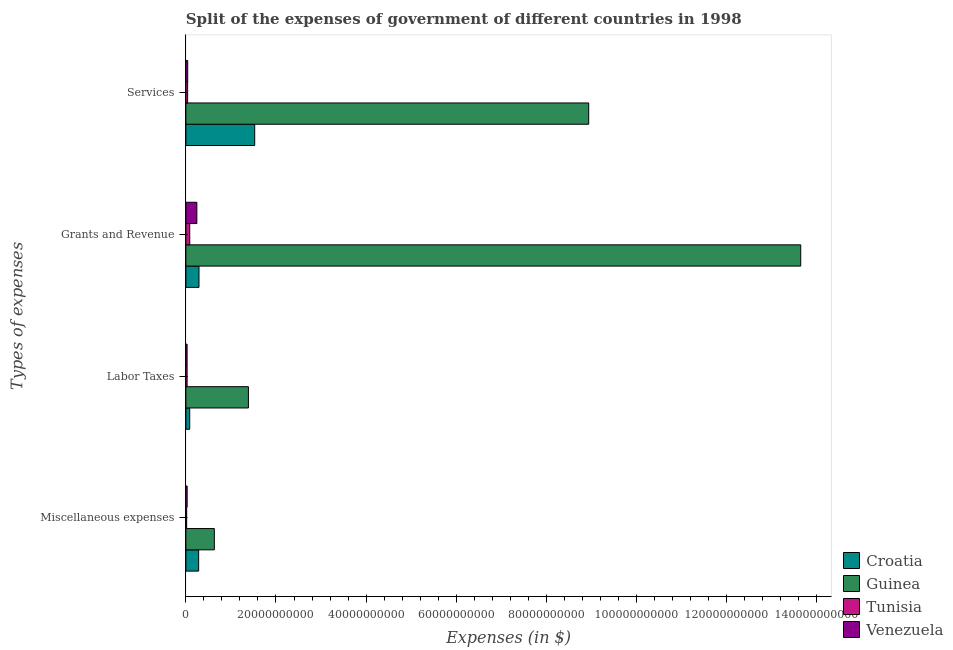Are the number of bars per tick equal to the number of legend labels?
Give a very brief answer. Yes. What is the label of the 2nd group of bars from the top?
Your answer should be compact. Grants and Revenue. What is the amount spent on miscellaneous expenses in Guinea?
Your answer should be compact. 6.32e+09. Across all countries, what is the maximum amount spent on labor taxes?
Your answer should be compact. 1.39e+1. Across all countries, what is the minimum amount spent on services?
Provide a short and direct response. 3.87e+08. In which country was the amount spent on services maximum?
Offer a very short reply. Guinea. In which country was the amount spent on services minimum?
Provide a succinct answer. Tunisia. What is the total amount spent on miscellaneous expenses in the graph?
Provide a succinct answer. 9.61e+09. What is the difference between the amount spent on grants and revenue in Croatia and that in Guinea?
Your answer should be compact. -1.34e+11. What is the difference between the amount spent on miscellaneous expenses in Guinea and the amount spent on services in Venezuela?
Provide a short and direct response. 5.91e+09. What is the average amount spent on labor taxes per country?
Keep it short and to the point. 3.82e+09. What is the difference between the amount spent on labor taxes and amount spent on miscellaneous expenses in Croatia?
Provide a short and direct response. -1.98e+09. What is the ratio of the amount spent on grants and revenue in Tunisia to that in Guinea?
Give a very brief answer. 0.01. What is the difference between the highest and the second highest amount spent on services?
Ensure brevity in your answer.  7.41e+1. What is the difference between the highest and the lowest amount spent on grants and revenue?
Your answer should be compact. 1.36e+11. Is the sum of the amount spent on miscellaneous expenses in Guinea and Tunisia greater than the maximum amount spent on services across all countries?
Your response must be concise. No. Is it the case that in every country, the sum of the amount spent on services and amount spent on labor taxes is greater than the sum of amount spent on grants and revenue and amount spent on miscellaneous expenses?
Ensure brevity in your answer.  No. What does the 1st bar from the top in Miscellaneous expenses represents?
Make the answer very short. Venezuela. What does the 4th bar from the bottom in Grants and Revenue represents?
Provide a short and direct response. Venezuela. How many bars are there?
Offer a terse response. 16. What is the difference between two consecutive major ticks on the X-axis?
Your answer should be compact. 2.00e+1. Does the graph contain any zero values?
Offer a terse response. No. Where does the legend appear in the graph?
Make the answer very short. Bottom right. How many legend labels are there?
Make the answer very short. 4. What is the title of the graph?
Your response must be concise. Split of the expenses of government of different countries in 1998. What is the label or title of the X-axis?
Your answer should be very brief. Expenses (in $). What is the label or title of the Y-axis?
Give a very brief answer. Types of expenses. What is the Expenses (in $) in Croatia in Miscellaneous expenses?
Offer a terse response. 2.84e+09. What is the Expenses (in $) in Guinea in Miscellaneous expenses?
Your answer should be very brief. 6.32e+09. What is the Expenses (in $) of Tunisia in Miscellaneous expenses?
Offer a terse response. 1.74e+08. What is the Expenses (in $) of Venezuela in Miscellaneous expenses?
Offer a very short reply. 2.82e+08. What is the Expenses (in $) of Croatia in Labor Taxes?
Provide a succinct answer. 8.52e+08. What is the Expenses (in $) in Guinea in Labor Taxes?
Your answer should be very brief. 1.39e+1. What is the Expenses (in $) in Tunisia in Labor Taxes?
Your response must be concise. 2.74e+08. What is the Expenses (in $) of Venezuela in Labor Taxes?
Provide a short and direct response. 2.68e+08. What is the Expenses (in $) in Croatia in Grants and Revenue?
Provide a short and direct response. 2.91e+09. What is the Expenses (in $) of Guinea in Grants and Revenue?
Provide a succinct answer. 1.36e+11. What is the Expenses (in $) in Tunisia in Grants and Revenue?
Provide a succinct answer. 8.56e+08. What is the Expenses (in $) of Venezuela in Grants and Revenue?
Your answer should be very brief. 2.43e+09. What is the Expenses (in $) of Croatia in Services?
Give a very brief answer. 1.53e+1. What is the Expenses (in $) in Guinea in Services?
Ensure brevity in your answer.  8.94e+1. What is the Expenses (in $) in Tunisia in Services?
Ensure brevity in your answer.  3.87e+08. What is the Expenses (in $) of Venezuela in Services?
Ensure brevity in your answer.  4.05e+08. Across all Types of expenses, what is the maximum Expenses (in $) in Croatia?
Your answer should be compact. 1.53e+1. Across all Types of expenses, what is the maximum Expenses (in $) in Guinea?
Your answer should be compact. 1.36e+11. Across all Types of expenses, what is the maximum Expenses (in $) of Tunisia?
Your answer should be very brief. 8.56e+08. Across all Types of expenses, what is the maximum Expenses (in $) in Venezuela?
Provide a short and direct response. 2.43e+09. Across all Types of expenses, what is the minimum Expenses (in $) of Croatia?
Offer a very short reply. 8.52e+08. Across all Types of expenses, what is the minimum Expenses (in $) of Guinea?
Make the answer very short. 6.32e+09. Across all Types of expenses, what is the minimum Expenses (in $) in Tunisia?
Offer a terse response. 1.74e+08. Across all Types of expenses, what is the minimum Expenses (in $) in Venezuela?
Provide a succinct answer. 2.68e+08. What is the total Expenses (in $) of Croatia in the graph?
Give a very brief answer. 2.19e+1. What is the total Expenses (in $) of Guinea in the graph?
Your answer should be very brief. 2.46e+11. What is the total Expenses (in $) of Tunisia in the graph?
Give a very brief answer. 1.69e+09. What is the total Expenses (in $) in Venezuela in the graph?
Your answer should be very brief. 3.39e+09. What is the difference between the Expenses (in $) in Croatia in Miscellaneous expenses and that in Labor Taxes?
Offer a very short reply. 1.98e+09. What is the difference between the Expenses (in $) of Guinea in Miscellaneous expenses and that in Labor Taxes?
Ensure brevity in your answer.  -7.57e+09. What is the difference between the Expenses (in $) of Tunisia in Miscellaneous expenses and that in Labor Taxes?
Your answer should be compact. -1.00e+08. What is the difference between the Expenses (in $) of Venezuela in Miscellaneous expenses and that in Labor Taxes?
Offer a terse response. 1.37e+07. What is the difference between the Expenses (in $) of Croatia in Miscellaneous expenses and that in Grants and Revenue?
Provide a succinct answer. -7.59e+07. What is the difference between the Expenses (in $) in Guinea in Miscellaneous expenses and that in Grants and Revenue?
Give a very brief answer. -1.30e+11. What is the difference between the Expenses (in $) in Tunisia in Miscellaneous expenses and that in Grants and Revenue?
Your answer should be compact. -6.82e+08. What is the difference between the Expenses (in $) in Venezuela in Miscellaneous expenses and that in Grants and Revenue?
Offer a very short reply. -2.15e+09. What is the difference between the Expenses (in $) in Croatia in Miscellaneous expenses and that in Services?
Offer a very short reply. -1.24e+1. What is the difference between the Expenses (in $) in Guinea in Miscellaneous expenses and that in Services?
Ensure brevity in your answer.  -8.31e+1. What is the difference between the Expenses (in $) of Tunisia in Miscellaneous expenses and that in Services?
Offer a terse response. -2.13e+08. What is the difference between the Expenses (in $) of Venezuela in Miscellaneous expenses and that in Services?
Give a very brief answer. -1.23e+08. What is the difference between the Expenses (in $) in Croatia in Labor Taxes and that in Grants and Revenue?
Your answer should be very brief. -2.06e+09. What is the difference between the Expenses (in $) of Guinea in Labor Taxes and that in Grants and Revenue?
Your answer should be compact. -1.23e+11. What is the difference between the Expenses (in $) in Tunisia in Labor Taxes and that in Grants and Revenue?
Offer a very short reply. -5.82e+08. What is the difference between the Expenses (in $) in Venezuela in Labor Taxes and that in Grants and Revenue?
Give a very brief answer. -2.17e+09. What is the difference between the Expenses (in $) of Croatia in Labor Taxes and that in Services?
Provide a succinct answer. -1.44e+1. What is the difference between the Expenses (in $) of Guinea in Labor Taxes and that in Services?
Provide a short and direct response. -7.55e+1. What is the difference between the Expenses (in $) in Tunisia in Labor Taxes and that in Services?
Your response must be concise. -1.13e+08. What is the difference between the Expenses (in $) of Venezuela in Labor Taxes and that in Services?
Give a very brief answer. -1.36e+08. What is the difference between the Expenses (in $) of Croatia in Grants and Revenue and that in Services?
Keep it short and to the point. -1.24e+1. What is the difference between the Expenses (in $) of Guinea in Grants and Revenue and that in Services?
Provide a short and direct response. 4.71e+1. What is the difference between the Expenses (in $) of Tunisia in Grants and Revenue and that in Services?
Provide a succinct answer. 4.69e+08. What is the difference between the Expenses (in $) of Venezuela in Grants and Revenue and that in Services?
Provide a short and direct response. 2.03e+09. What is the difference between the Expenses (in $) in Croatia in Miscellaneous expenses and the Expenses (in $) in Guinea in Labor Taxes?
Offer a terse response. -1.10e+1. What is the difference between the Expenses (in $) in Croatia in Miscellaneous expenses and the Expenses (in $) in Tunisia in Labor Taxes?
Your answer should be very brief. 2.56e+09. What is the difference between the Expenses (in $) in Croatia in Miscellaneous expenses and the Expenses (in $) in Venezuela in Labor Taxes?
Provide a succinct answer. 2.57e+09. What is the difference between the Expenses (in $) of Guinea in Miscellaneous expenses and the Expenses (in $) of Tunisia in Labor Taxes?
Offer a very short reply. 6.04e+09. What is the difference between the Expenses (in $) of Guinea in Miscellaneous expenses and the Expenses (in $) of Venezuela in Labor Taxes?
Offer a terse response. 6.05e+09. What is the difference between the Expenses (in $) in Tunisia in Miscellaneous expenses and the Expenses (in $) in Venezuela in Labor Taxes?
Offer a very short reply. -9.40e+07. What is the difference between the Expenses (in $) in Croatia in Miscellaneous expenses and the Expenses (in $) in Guinea in Grants and Revenue?
Your answer should be compact. -1.34e+11. What is the difference between the Expenses (in $) in Croatia in Miscellaneous expenses and the Expenses (in $) in Tunisia in Grants and Revenue?
Your answer should be very brief. 1.98e+09. What is the difference between the Expenses (in $) of Croatia in Miscellaneous expenses and the Expenses (in $) of Venezuela in Grants and Revenue?
Keep it short and to the point. 4.02e+08. What is the difference between the Expenses (in $) of Guinea in Miscellaneous expenses and the Expenses (in $) of Tunisia in Grants and Revenue?
Offer a terse response. 5.46e+09. What is the difference between the Expenses (in $) of Guinea in Miscellaneous expenses and the Expenses (in $) of Venezuela in Grants and Revenue?
Your answer should be very brief. 3.88e+09. What is the difference between the Expenses (in $) in Tunisia in Miscellaneous expenses and the Expenses (in $) in Venezuela in Grants and Revenue?
Provide a short and direct response. -2.26e+09. What is the difference between the Expenses (in $) of Croatia in Miscellaneous expenses and the Expenses (in $) of Guinea in Services?
Make the answer very short. -8.66e+1. What is the difference between the Expenses (in $) in Croatia in Miscellaneous expenses and the Expenses (in $) in Tunisia in Services?
Give a very brief answer. 2.45e+09. What is the difference between the Expenses (in $) of Croatia in Miscellaneous expenses and the Expenses (in $) of Venezuela in Services?
Provide a succinct answer. 2.43e+09. What is the difference between the Expenses (in $) in Guinea in Miscellaneous expenses and the Expenses (in $) in Tunisia in Services?
Your answer should be very brief. 5.93e+09. What is the difference between the Expenses (in $) in Guinea in Miscellaneous expenses and the Expenses (in $) in Venezuela in Services?
Offer a terse response. 5.91e+09. What is the difference between the Expenses (in $) of Tunisia in Miscellaneous expenses and the Expenses (in $) of Venezuela in Services?
Offer a terse response. -2.31e+08. What is the difference between the Expenses (in $) in Croatia in Labor Taxes and the Expenses (in $) in Guinea in Grants and Revenue?
Ensure brevity in your answer.  -1.36e+11. What is the difference between the Expenses (in $) in Croatia in Labor Taxes and the Expenses (in $) in Tunisia in Grants and Revenue?
Provide a succinct answer. -4.66e+06. What is the difference between the Expenses (in $) of Croatia in Labor Taxes and the Expenses (in $) of Venezuela in Grants and Revenue?
Your answer should be compact. -1.58e+09. What is the difference between the Expenses (in $) in Guinea in Labor Taxes and the Expenses (in $) in Tunisia in Grants and Revenue?
Keep it short and to the point. 1.30e+1. What is the difference between the Expenses (in $) in Guinea in Labor Taxes and the Expenses (in $) in Venezuela in Grants and Revenue?
Your answer should be compact. 1.14e+1. What is the difference between the Expenses (in $) in Tunisia in Labor Taxes and the Expenses (in $) in Venezuela in Grants and Revenue?
Your response must be concise. -2.16e+09. What is the difference between the Expenses (in $) of Croatia in Labor Taxes and the Expenses (in $) of Guinea in Services?
Offer a terse response. -8.86e+1. What is the difference between the Expenses (in $) of Croatia in Labor Taxes and the Expenses (in $) of Tunisia in Services?
Your answer should be very brief. 4.64e+08. What is the difference between the Expenses (in $) in Croatia in Labor Taxes and the Expenses (in $) in Venezuela in Services?
Provide a succinct answer. 4.47e+08. What is the difference between the Expenses (in $) in Guinea in Labor Taxes and the Expenses (in $) in Tunisia in Services?
Provide a succinct answer. 1.35e+1. What is the difference between the Expenses (in $) of Guinea in Labor Taxes and the Expenses (in $) of Venezuela in Services?
Provide a short and direct response. 1.35e+1. What is the difference between the Expenses (in $) of Tunisia in Labor Taxes and the Expenses (in $) of Venezuela in Services?
Your response must be concise. -1.30e+08. What is the difference between the Expenses (in $) of Croatia in Grants and Revenue and the Expenses (in $) of Guinea in Services?
Offer a very short reply. -8.65e+1. What is the difference between the Expenses (in $) in Croatia in Grants and Revenue and the Expenses (in $) in Tunisia in Services?
Your answer should be very brief. 2.53e+09. What is the difference between the Expenses (in $) in Croatia in Grants and Revenue and the Expenses (in $) in Venezuela in Services?
Ensure brevity in your answer.  2.51e+09. What is the difference between the Expenses (in $) of Guinea in Grants and Revenue and the Expenses (in $) of Tunisia in Services?
Your answer should be compact. 1.36e+11. What is the difference between the Expenses (in $) of Guinea in Grants and Revenue and the Expenses (in $) of Venezuela in Services?
Your response must be concise. 1.36e+11. What is the difference between the Expenses (in $) in Tunisia in Grants and Revenue and the Expenses (in $) in Venezuela in Services?
Keep it short and to the point. 4.51e+08. What is the average Expenses (in $) of Croatia per Types of expenses?
Offer a terse response. 5.47e+09. What is the average Expenses (in $) of Guinea per Types of expenses?
Offer a very short reply. 6.15e+1. What is the average Expenses (in $) of Tunisia per Types of expenses?
Your answer should be compact. 4.23e+08. What is the average Expenses (in $) in Venezuela per Types of expenses?
Your answer should be very brief. 8.48e+08. What is the difference between the Expenses (in $) in Croatia and Expenses (in $) in Guinea in Miscellaneous expenses?
Your answer should be very brief. -3.48e+09. What is the difference between the Expenses (in $) of Croatia and Expenses (in $) of Tunisia in Miscellaneous expenses?
Your response must be concise. 2.66e+09. What is the difference between the Expenses (in $) in Croatia and Expenses (in $) in Venezuela in Miscellaneous expenses?
Provide a short and direct response. 2.55e+09. What is the difference between the Expenses (in $) of Guinea and Expenses (in $) of Tunisia in Miscellaneous expenses?
Give a very brief answer. 6.14e+09. What is the difference between the Expenses (in $) of Guinea and Expenses (in $) of Venezuela in Miscellaneous expenses?
Ensure brevity in your answer.  6.03e+09. What is the difference between the Expenses (in $) of Tunisia and Expenses (in $) of Venezuela in Miscellaneous expenses?
Offer a terse response. -1.08e+08. What is the difference between the Expenses (in $) in Croatia and Expenses (in $) in Guinea in Labor Taxes?
Offer a terse response. -1.30e+1. What is the difference between the Expenses (in $) in Croatia and Expenses (in $) in Tunisia in Labor Taxes?
Offer a very short reply. 5.77e+08. What is the difference between the Expenses (in $) of Croatia and Expenses (in $) of Venezuela in Labor Taxes?
Keep it short and to the point. 5.83e+08. What is the difference between the Expenses (in $) in Guinea and Expenses (in $) in Tunisia in Labor Taxes?
Offer a terse response. 1.36e+1. What is the difference between the Expenses (in $) in Guinea and Expenses (in $) in Venezuela in Labor Taxes?
Offer a very short reply. 1.36e+1. What is the difference between the Expenses (in $) in Tunisia and Expenses (in $) in Venezuela in Labor Taxes?
Keep it short and to the point. 6.08e+06. What is the difference between the Expenses (in $) of Croatia and Expenses (in $) of Guinea in Grants and Revenue?
Your answer should be very brief. -1.34e+11. What is the difference between the Expenses (in $) of Croatia and Expenses (in $) of Tunisia in Grants and Revenue?
Provide a short and direct response. 2.06e+09. What is the difference between the Expenses (in $) in Croatia and Expenses (in $) in Venezuela in Grants and Revenue?
Make the answer very short. 4.78e+08. What is the difference between the Expenses (in $) in Guinea and Expenses (in $) in Tunisia in Grants and Revenue?
Your response must be concise. 1.36e+11. What is the difference between the Expenses (in $) in Guinea and Expenses (in $) in Venezuela in Grants and Revenue?
Give a very brief answer. 1.34e+11. What is the difference between the Expenses (in $) in Tunisia and Expenses (in $) in Venezuela in Grants and Revenue?
Your answer should be compact. -1.58e+09. What is the difference between the Expenses (in $) of Croatia and Expenses (in $) of Guinea in Services?
Give a very brief answer. -7.41e+1. What is the difference between the Expenses (in $) in Croatia and Expenses (in $) in Tunisia in Services?
Provide a short and direct response. 1.49e+1. What is the difference between the Expenses (in $) of Croatia and Expenses (in $) of Venezuela in Services?
Provide a succinct answer. 1.49e+1. What is the difference between the Expenses (in $) in Guinea and Expenses (in $) in Tunisia in Services?
Your answer should be compact. 8.90e+1. What is the difference between the Expenses (in $) in Guinea and Expenses (in $) in Venezuela in Services?
Give a very brief answer. 8.90e+1. What is the difference between the Expenses (in $) in Tunisia and Expenses (in $) in Venezuela in Services?
Your answer should be very brief. -1.76e+07. What is the ratio of the Expenses (in $) in Croatia in Miscellaneous expenses to that in Labor Taxes?
Make the answer very short. 3.33. What is the ratio of the Expenses (in $) of Guinea in Miscellaneous expenses to that in Labor Taxes?
Keep it short and to the point. 0.46. What is the ratio of the Expenses (in $) of Tunisia in Miscellaneous expenses to that in Labor Taxes?
Make the answer very short. 0.64. What is the ratio of the Expenses (in $) in Venezuela in Miscellaneous expenses to that in Labor Taxes?
Give a very brief answer. 1.05. What is the ratio of the Expenses (in $) of Croatia in Miscellaneous expenses to that in Grants and Revenue?
Offer a terse response. 0.97. What is the ratio of the Expenses (in $) in Guinea in Miscellaneous expenses to that in Grants and Revenue?
Your answer should be very brief. 0.05. What is the ratio of the Expenses (in $) in Tunisia in Miscellaneous expenses to that in Grants and Revenue?
Your response must be concise. 0.2. What is the ratio of the Expenses (in $) in Venezuela in Miscellaneous expenses to that in Grants and Revenue?
Your response must be concise. 0.12. What is the ratio of the Expenses (in $) in Croatia in Miscellaneous expenses to that in Services?
Give a very brief answer. 0.19. What is the ratio of the Expenses (in $) in Guinea in Miscellaneous expenses to that in Services?
Provide a succinct answer. 0.07. What is the ratio of the Expenses (in $) in Tunisia in Miscellaneous expenses to that in Services?
Provide a short and direct response. 0.45. What is the ratio of the Expenses (in $) of Venezuela in Miscellaneous expenses to that in Services?
Your answer should be very brief. 0.7. What is the ratio of the Expenses (in $) in Croatia in Labor Taxes to that in Grants and Revenue?
Offer a terse response. 0.29. What is the ratio of the Expenses (in $) in Guinea in Labor Taxes to that in Grants and Revenue?
Give a very brief answer. 0.1. What is the ratio of the Expenses (in $) in Tunisia in Labor Taxes to that in Grants and Revenue?
Ensure brevity in your answer.  0.32. What is the ratio of the Expenses (in $) in Venezuela in Labor Taxes to that in Grants and Revenue?
Your response must be concise. 0.11. What is the ratio of the Expenses (in $) of Croatia in Labor Taxes to that in Services?
Ensure brevity in your answer.  0.06. What is the ratio of the Expenses (in $) in Guinea in Labor Taxes to that in Services?
Keep it short and to the point. 0.16. What is the ratio of the Expenses (in $) in Tunisia in Labor Taxes to that in Services?
Offer a terse response. 0.71. What is the ratio of the Expenses (in $) of Venezuela in Labor Taxes to that in Services?
Provide a short and direct response. 0.66. What is the ratio of the Expenses (in $) of Croatia in Grants and Revenue to that in Services?
Provide a succinct answer. 0.19. What is the ratio of the Expenses (in $) in Guinea in Grants and Revenue to that in Services?
Your response must be concise. 1.53. What is the ratio of the Expenses (in $) in Tunisia in Grants and Revenue to that in Services?
Keep it short and to the point. 2.21. What is the ratio of the Expenses (in $) of Venezuela in Grants and Revenue to that in Services?
Your response must be concise. 6.01. What is the difference between the highest and the second highest Expenses (in $) of Croatia?
Your answer should be compact. 1.24e+1. What is the difference between the highest and the second highest Expenses (in $) of Guinea?
Your response must be concise. 4.71e+1. What is the difference between the highest and the second highest Expenses (in $) in Tunisia?
Make the answer very short. 4.69e+08. What is the difference between the highest and the second highest Expenses (in $) in Venezuela?
Offer a terse response. 2.03e+09. What is the difference between the highest and the lowest Expenses (in $) of Croatia?
Your response must be concise. 1.44e+1. What is the difference between the highest and the lowest Expenses (in $) of Guinea?
Provide a succinct answer. 1.30e+11. What is the difference between the highest and the lowest Expenses (in $) in Tunisia?
Make the answer very short. 6.82e+08. What is the difference between the highest and the lowest Expenses (in $) in Venezuela?
Your response must be concise. 2.17e+09. 